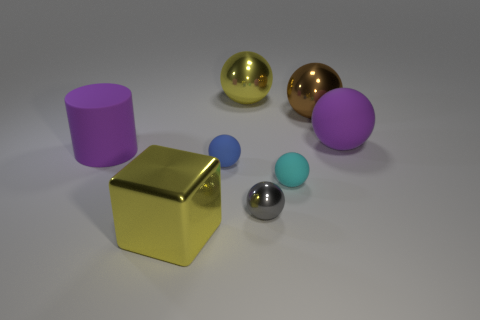Subtract 2 balls. How many balls are left? 4 Subtract all blue balls. How many balls are left? 5 Subtract all small metallic spheres. How many spheres are left? 5 Subtract all blue cylinders. Subtract all green spheres. How many cylinders are left? 1 Add 1 matte cylinders. How many objects exist? 9 Subtract all balls. How many objects are left? 2 Add 5 small yellow rubber objects. How many small yellow rubber objects exist? 5 Subtract 1 purple cylinders. How many objects are left? 7 Subtract all yellow shiny spheres. Subtract all yellow objects. How many objects are left? 5 Add 5 large purple rubber cylinders. How many large purple rubber cylinders are left? 6 